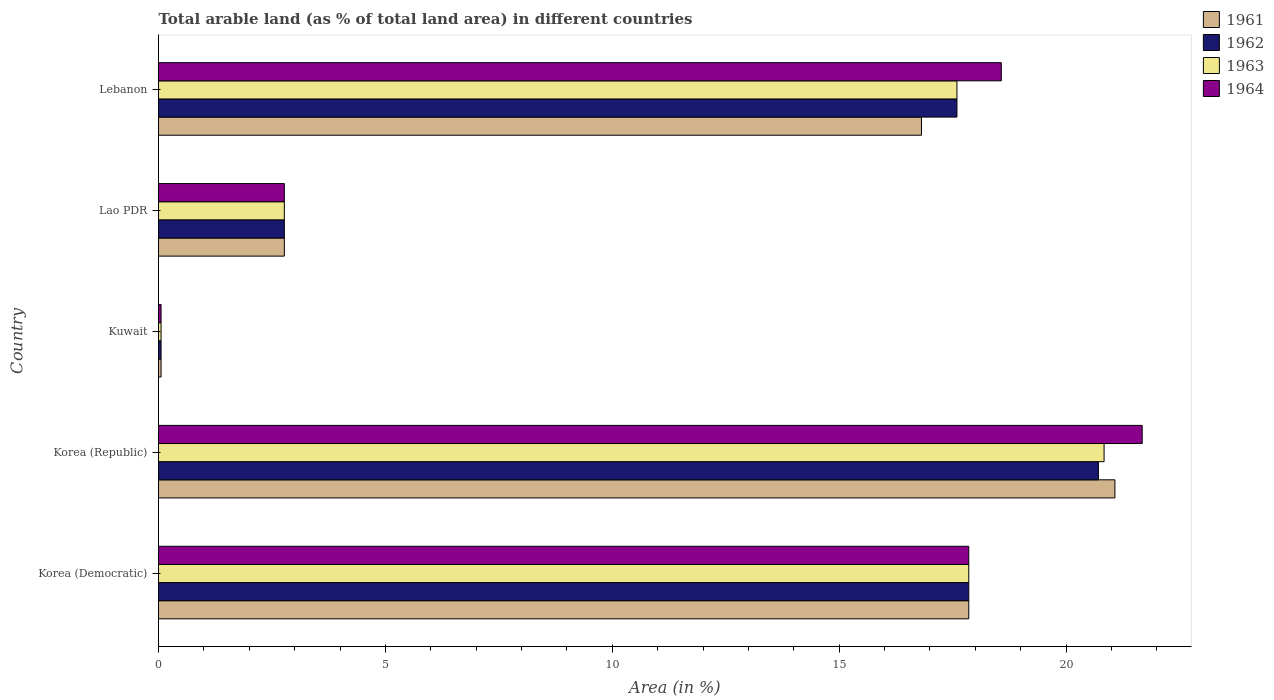How many different coloured bars are there?
Give a very brief answer. 4. How many groups of bars are there?
Your answer should be very brief. 5. Are the number of bars per tick equal to the number of legend labels?
Ensure brevity in your answer.  Yes. What is the label of the 1st group of bars from the top?
Offer a very short reply. Lebanon. What is the percentage of arable land in 1963 in Lao PDR?
Provide a short and direct response. 2.77. Across all countries, what is the maximum percentage of arable land in 1964?
Your response must be concise. 21.68. Across all countries, what is the minimum percentage of arable land in 1964?
Give a very brief answer. 0.06. In which country was the percentage of arable land in 1962 minimum?
Offer a very short reply. Kuwait. What is the total percentage of arable land in 1961 in the graph?
Make the answer very short. 58.57. What is the difference between the percentage of arable land in 1961 in Kuwait and that in Lao PDR?
Ensure brevity in your answer.  -2.72. What is the difference between the percentage of arable land in 1961 in Korea (Republic) and the percentage of arable land in 1962 in Korea (Democratic)?
Keep it short and to the point. 3.22. What is the average percentage of arable land in 1963 per country?
Your answer should be very brief. 11.82. What is the difference between the percentage of arable land in 1961 and percentage of arable land in 1963 in Kuwait?
Give a very brief answer. 0. In how many countries, is the percentage of arable land in 1962 greater than 13 %?
Give a very brief answer. 3. What is the ratio of the percentage of arable land in 1962 in Lao PDR to that in Lebanon?
Your response must be concise. 0.16. Is the percentage of arable land in 1961 in Kuwait less than that in Lebanon?
Provide a short and direct response. Yes. What is the difference between the highest and the second highest percentage of arable land in 1962?
Offer a very short reply. 2.86. What is the difference between the highest and the lowest percentage of arable land in 1962?
Your response must be concise. 20.66. Is the sum of the percentage of arable land in 1962 in Lao PDR and Lebanon greater than the maximum percentage of arable land in 1961 across all countries?
Provide a short and direct response. No. Is it the case that in every country, the sum of the percentage of arable land in 1962 and percentage of arable land in 1964 is greater than the sum of percentage of arable land in 1961 and percentage of arable land in 1963?
Make the answer very short. No. What does the 4th bar from the top in Kuwait represents?
Offer a very short reply. 1961. What does the 4th bar from the bottom in Korea (Democratic) represents?
Give a very brief answer. 1964. How many bars are there?
Ensure brevity in your answer.  20. Are all the bars in the graph horizontal?
Keep it short and to the point. Yes. How many countries are there in the graph?
Provide a succinct answer. 5. Are the values on the major ticks of X-axis written in scientific E-notation?
Provide a succinct answer. No. Does the graph contain any zero values?
Keep it short and to the point. No. How many legend labels are there?
Provide a succinct answer. 4. How are the legend labels stacked?
Ensure brevity in your answer.  Vertical. What is the title of the graph?
Your answer should be compact. Total arable land (as % of total land area) in different countries. What is the label or title of the X-axis?
Your answer should be compact. Area (in %). What is the Area (in %) of 1961 in Korea (Democratic)?
Keep it short and to the point. 17.86. What is the Area (in %) in 1962 in Korea (Democratic)?
Provide a short and direct response. 17.86. What is the Area (in %) of 1963 in Korea (Democratic)?
Keep it short and to the point. 17.86. What is the Area (in %) in 1964 in Korea (Democratic)?
Make the answer very short. 17.86. What is the Area (in %) of 1961 in Korea (Republic)?
Keep it short and to the point. 21.08. What is the Area (in %) of 1962 in Korea (Republic)?
Provide a succinct answer. 20.71. What is the Area (in %) in 1963 in Korea (Republic)?
Make the answer very short. 20.84. What is the Area (in %) in 1964 in Korea (Republic)?
Your response must be concise. 21.68. What is the Area (in %) in 1961 in Kuwait?
Your answer should be very brief. 0.06. What is the Area (in %) of 1962 in Kuwait?
Provide a succinct answer. 0.06. What is the Area (in %) of 1963 in Kuwait?
Keep it short and to the point. 0.06. What is the Area (in %) in 1964 in Kuwait?
Keep it short and to the point. 0.06. What is the Area (in %) of 1961 in Lao PDR?
Your answer should be very brief. 2.77. What is the Area (in %) of 1962 in Lao PDR?
Your answer should be compact. 2.77. What is the Area (in %) in 1963 in Lao PDR?
Offer a very short reply. 2.77. What is the Area (in %) in 1964 in Lao PDR?
Your answer should be very brief. 2.77. What is the Area (in %) in 1961 in Lebanon?
Offer a terse response. 16.81. What is the Area (in %) of 1962 in Lebanon?
Provide a succinct answer. 17.6. What is the Area (in %) of 1963 in Lebanon?
Offer a very short reply. 17.6. What is the Area (in %) in 1964 in Lebanon?
Give a very brief answer. 18.57. Across all countries, what is the maximum Area (in %) in 1961?
Make the answer very short. 21.08. Across all countries, what is the maximum Area (in %) of 1962?
Offer a very short reply. 20.71. Across all countries, what is the maximum Area (in %) of 1963?
Offer a terse response. 20.84. Across all countries, what is the maximum Area (in %) of 1964?
Make the answer very short. 21.68. Across all countries, what is the minimum Area (in %) in 1961?
Keep it short and to the point. 0.06. Across all countries, what is the minimum Area (in %) of 1962?
Your answer should be very brief. 0.06. Across all countries, what is the minimum Area (in %) in 1963?
Your response must be concise. 0.06. Across all countries, what is the minimum Area (in %) in 1964?
Offer a terse response. 0.06. What is the total Area (in %) of 1961 in the graph?
Keep it short and to the point. 58.57. What is the total Area (in %) of 1962 in the graph?
Your answer should be compact. 58.99. What is the total Area (in %) in 1963 in the graph?
Keep it short and to the point. 59.12. What is the total Area (in %) of 1964 in the graph?
Your answer should be very brief. 60.93. What is the difference between the Area (in %) in 1961 in Korea (Democratic) and that in Korea (Republic)?
Offer a terse response. -3.22. What is the difference between the Area (in %) of 1962 in Korea (Democratic) and that in Korea (Republic)?
Ensure brevity in your answer.  -2.86. What is the difference between the Area (in %) of 1963 in Korea (Democratic) and that in Korea (Republic)?
Your answer should be very brief. -2.98. What is the difference between the Area (in %) of 1964 in Korea (Democratic) and that in Korea (Republic)?
Make the answer very short. -3.82. What is the difference between the Area (in %) in 1961 in Korea (Democratic) and that in Kuwait?
Your answer should be compact. 17.8. What is the difference between the Area (in %) in 1962 in Korea (Democratic) and that in Kuwait?
Make the answer very short. 17.8. What is the difference between the Area (in %) of 1963 in Korea (Democratic) and that in Kuwait?
Give a very brief answer. 17.8. What is the difference between the Area (in %) in 1964 in Korea (Democratic) and that in Kuwait?
Your response must be concise. 17.8. What is the difference between the Area (in %) in 1961 in Korea (Democratic) and that in Lao PDR?
Give a very brief answer. 15.08. What is the difference between the Area (in %) of 1962 in Korea (Democratic) and that in Lao PDR?
Ensure brevity in your answer.  15.08. What is the difference between the Area (in %) in 1963 in Korea (Democratic) and that in Lao PDR?
Your answer should be compact. 15.08. What is the difference between the Area (in %) of 1964 in Korea (Democratic) and that in Lao PDR?
Offer a very short reply. 15.08. What is the difference between the Area (in %) of 1961 in Korea (Democratic) and that in Lebanon?
Ensure brevity in your answer.  1.04. What is the difference between the Area (in %) of 1962 in Korea (Democratic) and that in Lebanon?
Your answer should be very brief. 0.26. What is the difference between the Area (in %) in 1963 in Korea (Democratic) and that in Lebanon?
Ensure brevity in your answer.  0.26. What is the difference between the Area (in %) in 1964 in Korea (Democratic) and that in Lebanon?
Offer a very short reply. -0.72. What is the difference between the Area (in %) in 1961 in Korea (Republic) and that in Kuwait?
Your response must be concise. 21.02. What is the difference between the Area (in %) in 1962 in Korea (Republic) and that in Kuwait?
Your answer should be very brief. 20.66. What is the difference between the Area (in %) in 1963 in Korea (Republic) and that in Kuwait?
Your response must be concise. 20.78. What is the difference between the Area (in %) in 1964 in Korea (Republic) and that in Kuwait?
Provide a short and direct response. 21.62. What is the difference between the Area (in %) of 1961 in Korea (Republic) and that in Lao PDR?
Ensure brevity in your answer.  18.3. What is the difference between the Area (in %) of 1962 in Korea (Republic) and that in Lao PDR?
Offer a very short reply. 17.94. What is the difference between the Area (in %) of 1963 in Korea (Republic) and that in Lao PDR?
Make the answer very short. 18.06. What is the difference between the Area (in %) of 1964 in Korea (Republic) and that in Lao PDR?
Keep it short and to the point. 18.9. What is the difference between the Area (in %) of 1961 in Korea (Republic) and that in Lebanon?
Ensure brevity in your answer.  4.26. What is the difference between the Area (in %) in 1962 in Korea (Republic) and that in Lebanon?
Provide a succinct answer. 3.12. What is the difference between the Area (in %) in 1963 in Korea (Republic) and that in Lebanon?
Provide a short and direct response. 3.24. What is the difference between the Area (in %) of 1964 in Korea (Republic) and that in Lebanon?
Your response must be concise. 3.1. What is the difference between the Area (in %) in 1961 in Kuwait and that in Lao PDR?
Make the answer very short. -2.72. What is the difference between the Area (in %) of 1962 in Kuwait and that in Lao PDR?
Make the answer very short. -2.72. What is the difference between the Area (in %) in 1963 in Kuwait and that in Lao PDR?
Your response must be concise. -2.72. What is the difference between the Area (in %) of 1964 in Kuwait and that in Lao PDR?
Provide a short and direct response. -2.72. What is the difference between the Area (in %) of 1961 in Kuwait and that in Lebanon?
Ensure brevity in your answer.  -16.76. What is the difference between the Area (in %) in 1962 in Kuwait and that in Lebanon?
Your answer should be very brief. -17.54. What is the difference between the Area (in %) of 1963 in Kuwait and that in Lebanon?
Keep it short and to the point. -17.54. What is the difference between the Area (in %) in 1964 in Kuwait and that in Lebanon?
Offer a terse response. -18.52. What is the difference between the Area (in %) in 1961 in Lao PDR and that in Lebanon?
Give a very brief answer. -14.04. What is the difference between the Area (in %) of 1962 in Lao PDR and that in Lebanon?
Your answer should be very brief. -14.82. What is the difference between the Area (in %) of 1963 in Lao PDR and that in Lebanon?
Keep it short and to the point. -14.82. What is the difference between the Area (in %) of 1964 in Lao PDR and that in Lebanon?
Make the answer very short. -15.8. What is the difference between the Area (in %) in 1961 in Korea (Democratic) and the Area (in %) in 1962 in Korea (Republic)?
Provide a short and direct response. -2.86. What is the difference between the Area (in %) in 1961 in Korea (Democratic) and the Area (in %) in 1963 in Korea (Republic)?
Your answer should be very brief. -2.98. What is the difference between the Area (in %) in 1961 in Korea (Democratic) and the Area (in %) in 1964 in Korea (Republic)?
Offer a very short reply. -3.82. What is the difference between the Area (in %) in 1962 in Korea (Democratic) and the Area (in %) in 1963 in Korea (Republic)?
Offer a very short reply. -2.98. What is the difference between the Area (in %) in 1962 in Korea (Democratic) and the Area (in %) in 1964 in Korea (Republic)?
Give a very brief answer. -3.82. What is the difference between the Area (in %) in 1963 in Korea (Democratic) and the Area (in %) in 1964 in Korea (Republic)?
Your response must be concise. -3.82. What is the difference between the Area (in %) in 1961 in Korea (Democratic) and the Area (in %) in 1962 in Kuwait?
Make the answer very short. 17.8. What is the difference between the Area (in %) in 1961 in Korea (Democratic) and the Area (in %) in 1963 in Kuwait?
Your response must be concise. 17.8. What is the difference between the Area (in %) of 1961 in Korea (Democratic) and the Area (in %) of 1964 in Kuwait?
Your answer should be compact. 17.8. What is the difference between the Area (in %) of 1962 in Korea (Democratic) and the Area (in %) of 1963 in Kuwait?
Your answer should be compact. 17.8. What is the difference between the Area (in %) in 1962 in Korea (Democratic) and the Area (in %) in 1964 in Kuwait?
Provide a short and direct response. 17.8. What is the difference between the Area (in %) of 1963 in Korea (Democratic) and the Area (in %) of 1964 in Kuwait?
Your answer should be very brief. 17.8. What is the difference between the Area (in %) in 1961 in Korea (Democratic) and the Area (in %) in 1962 in Lao PDR?
Make the answer very short. 15.08. What is the difference between the Area (in %) in 1961 in Korea (Democratic) and the Area (in %) in 1963 in Lao PDR?
Provide a short and direct response. 15.08. What is the difference between the Area (in %) of 1961 in Korea (Democratic) and the Area (in %) of 1964 in Lao PDR?
Your answer should be very brief. 15.08. What is the difference between the Area (in %) of 1962 in Korea (Democratic) and the Area (in %) of 1963 in Lao PDR?
Offer a very short reply. 15.08. What is the difference between the Area (in %) of 1962 in Korea (Democratic) and the Area (in %) of 1964 in Lao PDR?
Ensure brevity in your answer.  15.08. What is the difference between the Area (in %) in 1963 in Korea (Democratic) and the Area (in %) in 1964 in Lao PDR?
Your response must be concise. 15.08. What is the difference between the Area (in %) in 1961 in Korea (Democratic) and the Area (in %) in 1962 in Lebanon?
Your response must be concise. 0.26. What is the difference between the Area (in %) in 1961 in Korea (Democratic) and the Area (in %) in 1963 in Lebanon?
Give a very brief answer. 0.26. What is the difference between the Area (in %) in 1961 in Korea (Democratic) and the Area (in %) in 1964 in Lebanon?
Make the answer very short. -0.72. What is the difference between the Area (in %) of 1962 in Korea (Democratic) and the Area (in %) of 1963 in Lebanon?
Ensure brevity in your answer.  0.26. What is the difference between the Area (in %) of 1962 in Korea (Democratic) and the Area (in %) of 1964 in Lebanon?
Your answer should be very brief. -0.72. What is the difference between the Area (in %) in 1963 in Korea (Democratic) and the Area (in %) in 1964 in Lebanon?
Offer a terse response. -0.72. What is the difference between the Area (in %) of 1961 in Korea (Republic) and the Area (in %) of 1962 in Kuwait?
Offer a terse response. 21.02. What is the difference between the Area (in %) of 1961 in Korea (Republic) and the Area (in %) of 1963 in Kuwait?
Your answer should be very brief. 21.02. What is the difference between the Area (in %) of 1961 in Korea (Republic) and the Area (in %) of 1964 in Kuwait?
Your answer should be compact. 21.02. What is the difference between the Area (in %) in 1962 in Korea (Republic) and the Area (in %) in 1963 in Kuwait?
Your response must be concise. 20.66. What is the difference between the Area (in %) in 1962 in Korea (Republic) and the Area (in %) in 1964 in Kuwait?
Your answer should be compact. 20.66. What is the difference between the Area (in %) of 1963 in Korea (Republic) and the Area (in %) of 1964 in Kuwait?
Offer a terse response. 20.78. What is the difference between the Area (in %) in 1961 in Korea (Republic) and the Area (in %) in 1962 in Lao PDR?
Make the answer very short. 18.3. What is the difference between the Area (in %) of 1961 in Korea (Republic) and the Area (in %) of 1963 in Lao PDR?
Your response must be concise. 18.3. What is the difference between the Area (in %) in 1961 in Korea (Republic) and the Area (in %) in 1964 in Lao PDR?
Keep it short and to the point. 18.3. What is the difference between the Area (in %) of 1962 in Korea (Republic) and the Area (in %) of 1963 in Lao PDR?
Provide a short and direct response. 17.94. What is the difference between the Area (in %) in 1962 in Korea (Republic) and the Area (in %) in 1964 in Lao PDR?
Give a very brief answer. 17.94. What is the difference between the Area (in %) of 1963 in Korea (Republic) and the Area (in %) of 1964 in Lao PDR?
Your answer should be compact. 18.06. What is the difference between the Area (in %) in 1961 in Korea (Republic) and the Area (in %) in 1962 in Lebanon?
Offer a terse response. 3.48. What is the difference between the Area (in %) in 1961 in Korea (Republic) and the Area (in %) in 1963 in Lebanon?
Your response must be concise. 3.48. What is the difference between the Area (in %) of 1961 in Korea (Republic) and the Area (in %) of 1964 in Lebanon?
Make the answer very short. 2.5. What is the difference between the Area (in %) in 1962 in Korea (Republic) and the Area (in %) in 1963 in Lebanon?
Keep it short and to the point. 3.12. What is the difference between the Area (in %) in 1962 in Korea (Republic) and the Area (in %) in 1964 in Lebanon?
Your response must be concise. 2.14. What is the difference between the Area (in %) of 1963 in Korea (Republic) and the Area (in %) of 1964 in Lebanon?
Keep it short and to the point. 2.26. What is the difference between the Area (in %) in 1961 in Kuwait and the Area (in %) in 1962 in Lao PDR?
Keep it short and to the point. -2.72. What is the difference between the Area (in %) in 1961 in Kuwait and the Area (in %) in 1963 in Lao PDR?
Give a very brief answer. -2.72. What is the difference between the Area (in %) of 1961 in Kuwait and the Area (in %) of 1964 in Lao PDR?
Offer a very short reply. -2.72. What is the difference between the Area (in %) of 1962 in Kuwait and the Area (in %) of 1963 in Lao PDR?
Keep it short and to the point. -2.72. What is the difference between the Area (in %) of 1962 in Kuwait and the Area (in %) of 1964 in Lao PDR?
Ensure brevity in your answer.  -2.72. What is the difference between the Area (in %) in 1963 in Kuwait and the Area (in %) in 1964 in Lao PDR?
Offer a terse response. -2.72. What is the difference between the Area (in %) in 1961 in Kuwait and the Area (in %) in 1962 in Lebanon?
Offer a terse response. -17.54. What is the difference between the Area (in %) of 1961 in Kuwait and the Area (in %) of 1963 in Lebanon?
Your answer should be compact. -17.54. What is the difference between the Area (in %) of 1961 in Kuwait and the Area (in %) of 1964 in Lebanon?
Provide a short and direct response. -18.52. What is the difference between the Area (in %) of 1962 in Kuwait and the Area (in %) of 1963 in Lebanon?
Keep it short and to the point. -17.54. What is the difference between the Area (in %) in 1962 in Kuwait and the Area (in %) in 1964 in Lebanon?
Provide a short and direct response. -18.52. What is the difference between the Area (in %) in 1963 in Kuwait and the Area (in %) in 1964 in Lebanon?
Give a very brief answer. -18.52. What is the difference between the Area (in %) of 1961 in Lao PDR and the Area (in %) of 1962 in Lebanon?
Make the answer very short. -14.82. What is the difference between the Area (in %) of 1961 in Lao PDR and the Area (in %) of 1963 in Lebanon?
Make the answer very short. -14.82. What is the difference between the Area (in %) in 1961 in Lao PDR and the Area (in %) in 1964 in Lebanon?
Your response must be concise. -15.8. What is the difference between the Area (in %) of 1962 in Lao PDR and the Area (in %) of 1963 in Lebanon?
Offer a terse response. -14.82. What is the difference between the Area (in %) of 1962 in Lao PDR and the Area (in %) of 1964 in Lebanon?
Your answer should be very brief. -15.8. What is the difference between the Area (in %) in 1963 in Lao PDR and the Area (in %) in 1964 in Lebanon?
Give a very brief answer. -15.8. What is the average Area (in %) in 1961 per country?
Your answer should be compact. 11.71. What is the average Area (in %) of 1962 per country?
Your answer should be compact. 11.8. What is the average Area (in %) of 1963 per country?
Make the answer very short. 11.82. What is the average Area (in %) of 1964 per country?
Provide a succinct answer. 12.19. What is the difference between the Area (in %) in 1961 and Area (in %) in 1962 in Korea (Democratic)?
Keep it short and to the point. 0. What is the difference between the Area (in %) in 1961 and Area (in %) in 1963 in Korea (Democratic)?
Provide a short and direct response. 0. What is the difference between the Area (in %) in 1963 and Area (in %) in 1964 in Korea (Democratic)?
Your answer should be compact. 0. What is the difference between the Area (in %) in 1961 and Area (in %) in 1962 in Korea (Republic)?
Provide a succinct answer. 0.36. What is the difference between the Area (in %) in 1961 and Area (in %) in 1963 in Korea (Republic)?
Provide a short and direct response. 0.24. What is the difference between the Area (in %) in 1961 and Area (in %) in 1964 in Korea (Republic)?
Your answer should be very brief. -0.6. What is the difference between the Area (in %) of 1962 and Area (in %) of 1963 in Korea (Republic)?
Your answer should be very brief. -0.12. What is the difference between the Area (in %) in 1962 and Area (in %) in 1964 in Korea (Republic)?
Offer a terse response. -0.96. What is the difference between the Area (in %) of 1963 and Area (in %) of 1964 in Korea (Republic)?
Your response must be concise. -0.84. What is the difference between the Area (in %) of 1961 and Area (in %) of 1964 in Kuwait?
Keep it short and to the point. 0. What is the difference between the Area (in %) of 1962 and Area (in %) of 1963 in Kuwait?
Your answer should be very brief. 0. What is the difference between the Area (in %) in 1962 and Area (in %) in 1963 in Lao PDR?
Offer a very short reply. 0. What is the difference between the Area (in %) of 1961 and Area (in %) of 1962 in Lebanon?
Keep it short and to the point. -0.78. What is the difference between the Area (in %) in 1961 and Area (in %) in 1963 in Lebanon?
Keep it short and to the point. -0.78. What is the difference between the Area (in %) of 1961 and Area (in %) of 1964 in Lebanon?
Give a very brief answer. -1.76. What is the difference between the Area (in %) in 1962 and Area (in %) in 1963 in Lebanon?
Your answer should be compact. 0. What is the difference between the Area (in %) of 1962 and Area (in %) of 1964 in Lebanon?
Offer a terse response. -0.98. What is the difference between the Area (in %) of 1963 and Area (in %) of 1964 in Lebanon?
Keep it short and to the point. -0.98. What is the ratio of the Area (in %) of 1961 in Korea (Democratic) to that in Korea (Republic)?
Keep it short and to the point. 0.85. What is the ratio of the Area (in %) in 1962 in Korea (Democratic) to that in Korea (Republic)?
Provide a short and direct response. 0.86. What is the ratio of the Area (in %) in 1963 in Korea (Democratic) to that in Korea (Republic)?
Provide a succinct answer. 0.86. What is the ratio of the Area (in %) of 1964 in Korea (Democratic) to that in Korea (Republic)?
Your answer should be compact. 0.82. What is the ratio of the Area (in %) in 1961 in Korea (Democratic) to that in Kuwait?
Make the answer very short. 318.19. What is the ratio of the Area (in %) of 1962 in Korea (Democratic) to that in Kuwait?
Offer a very short reply. 318.19. What is the ratio of the Area (in %) in 1963 in Korea (Democratic) to that in Kuwait?
Your response must be concise. 318.19. What is the ratio of the Area (in %) in 1964 in Korea (Democratic) to that in Kuwait?
Your answer should be compact. 318.19. What is the ratio of the Area (in %) in 1961 in Korea (Democratic) to that in Lao PDR?
Ensure brevity in your answer.  6.44. What is the ratio of the Area (in %) of 1962 in Korea (Democratic) to that in Lao PDR?
Keep it short and to the point. 6.44. What is the ratio of the Area (in %) of 1963 in Korea (Democratic) to that in Lao PDR?
Make the answer very short. 6.44. What is the ratio of the Area (in %) of 1964 in Korea (Democratic) to that in Lao PDR?
Your answer should be compact. 6.44. What is the ratio of the Area (in %) in 1961 in Korea (Democratic) to that in Lebanon?
Offer a terse response. 1.06. What is the ratio of the Area (in %) in 1962 in Korea (Democratic) to that in Lebanon?
Provide a short and direct response. 1.01. What is the ratio of the Area (in %) of 1963 in Korea (Democratic) to that in Lebanon?
Ensure brevity in your answer.  1.01. What is the ratio of the Area (in %) of 1964 in Korea (Democratic) to that in Lebanon?
Offer a terse response. 0.96. What is the ratio of the Area (in %) of 1961 in Korea (Republic) to that in Kuwait?
Your answer should be very brief. 375.58. What is the ratio of the Area (in %) in 1962 in Korea (Republic) to that in Kuwait?
Your answer should be compact. 369.11. What is the ratio of the Area (in %) in 1963 in Korea (Republic) to that in Kuwait?
Give a very brief answer. 371.33. What is the ratio of the Area (in %) in 1964 in Korea (Republic) to that in Kuwait?
Provide a short and direct response. 386.29. What is the ratio of the Area (in %) of 1961 in Korea (Republic) to that in Lao PDR?
Your answer should be very brief. 7.6. What is the ratio of the Area (in %) of 1962 in Korea (Republic) to that in Lao PDR?
Offer a terse response. 7.47. What is the ratio of the Area (in %) of 1963 in Korea (Republic) to that in Lao PDR?
Give a very brief answer. 7.51. What is the ratio of the Area (in %) of 1964 in Korea (Republic) to that in Lao PDR?
Make the answer very short. 7.82. What is the ratio of the Area (in %) in 1961 in Korea (Republic) to that in Lebanon?
Ensure brevity in your answer.  1.25. What is the ratio of the Area (in %) in 1962 in Korea (Republic) to that in Lebanon?
Give a very brief answer. 1.18. What is the ratio of the Area (in %) of 1963 in Korea (Republic) to that in Lebanon?
Offer a very short reply. 1.18. What is the ratio of the Area (in %) of 1964 in Korea (Republic) to that in Lebanon?
Provide a short and direct response. 1.17. What is the ratio of the Area (in %) in 1961 in Kuwait to that in Lao PDR?
Provide a short and direct response. 0.02. What is the ratio of the Area (in %) of 1962 in Kuwait to that in Lao PDR?
Provide a succinct answer. 0.02. What is the ratio of the Area (in %) in 1963 in Kuwait to that in Lao PDR?
Your answer should be compact. 0.02. What is the ratio of the Area (in %) in 1964 in Kuwait to that in Lao PDR?
Offer a very short reply. 0.02. What is the ratio of the Area (in %) of 1961 in Kuwait to that in Lebanon?
Your response must be concise. 0. What is the ratio of the Area (in %) in 1962 in Kuwait to that in Lebanon?
Offer a terse response. 0. What is the ratio of the Area (in %) in 1963 in Kuwait to that in Lebanon?
Your answer should be compact. 0. What is the ratio of the Area (in %) in 1964 in Kuwait to that in Lebanon?
Provide a short and direct response. 0. What is the ratio of the Area (in %) of 1961 in Lao PDR to that in Lebanon?
Provide a succinct answer. 0.16. What is the ratio of the Area (in %) of 1962 in Lao PDR to that in Lebanon?
Provide a short and direct response. 0.16. What is the ratio of the Area (in %) in 1963 in Lao PDR to that in Lebanon?
Your answer should be compact. 0.16. What is the ratio of the Area (in %) of 1964 in Lao PDR to that in Lebanon?
Make the answer very short. 0.15. What is the difference between the highest and the second highest Area (in %) in 1961?
Your answer should be very brief. 3.22. What is the difference between the highest and the second highest Area (in %) in 1962?
Provide a short and direct response. 2.86. What is the difference between the highest and the second highest Area (in %) of 1963?
Provide a succinct answer. 2.98. What is the difference between the highest and the second highest Area (in %) in 1964?
Make the answer very short. 3.1. What is the difference between the highest and the lowest Area (in %) of 1961?
Your answer should be very brief. 21.02. What is the difference between the highest and the lowest Area (in %) in 1962?
Your response must be concise. 20.66. What is the difference between the highest and the lowest Area (in %) in 1963?
Keep it short and to the point. 20.78. What is the difference between the highest and the lowest Area (in %) of 1964?
Your response must be concise. 21.62. 